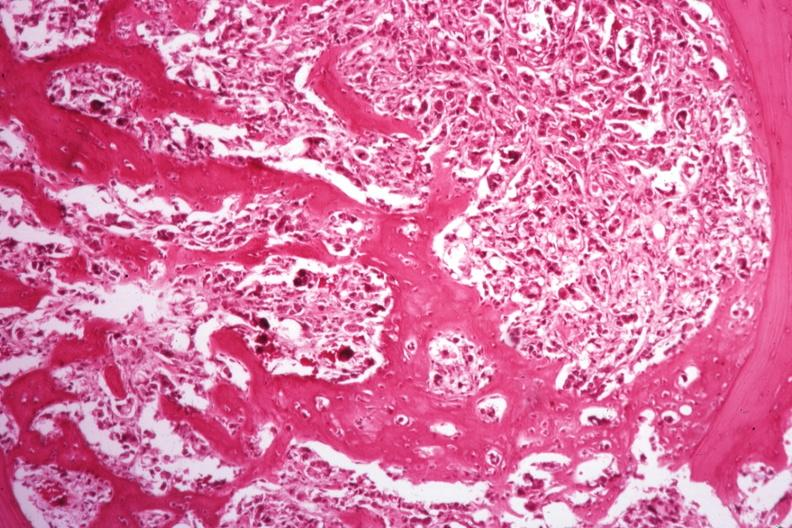does spleen show islands of tumor with nice new bone formation?
Answer the question using a single word or phrase. No 